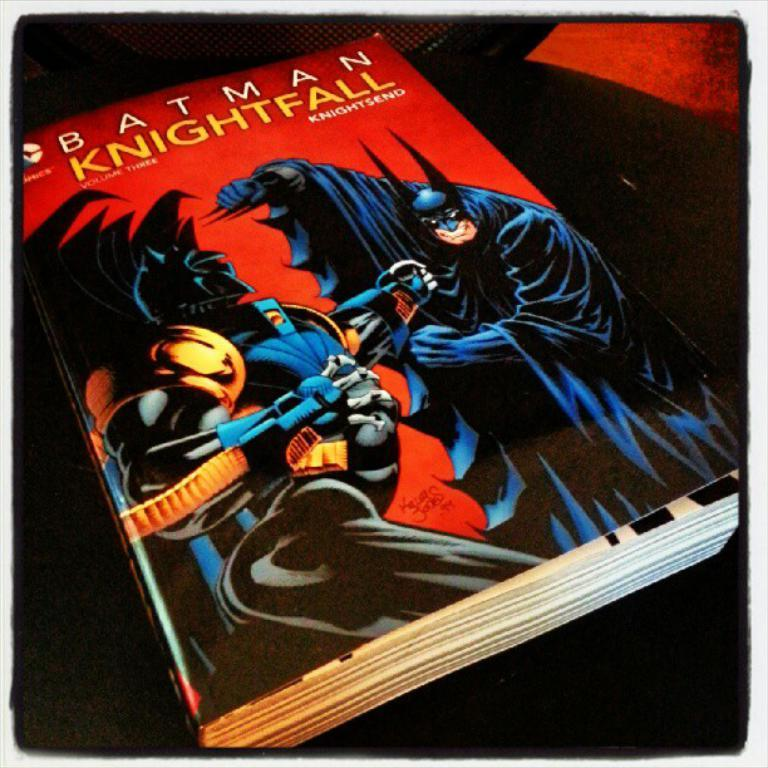<image>
Describe the image concisely. A thick book for Batman Knightfall showing the character fighting another character. 